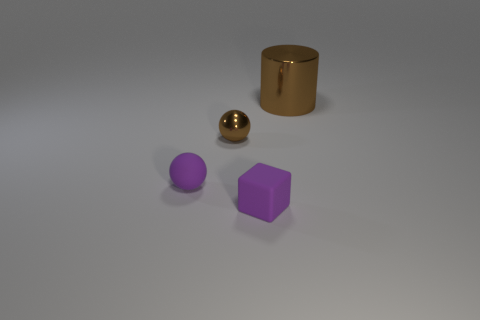Is there any other thing that has the same size as the brown cylinder?
Offer a very short reply. No. Are there more small brown balls that are on the right side of the tiny brown ball than tiny purple rubber cubes that are on the left side of the big metal thing?
Provide a short and direct response. No. There is a small thing that is in front of the purple ball; what material is it?
Ensure brevity in your answer.  Rubber. Does the tiny brown object have the same shape as the big brown object?
Offer a very short reply. No. Is there anything else that has the same color as the cylinder?
Give a very brief answer. Yes. There is another object that is the same shape as the small brown metallic thing; what color is it?
Your answer should be compact. Purple. Are there more purple balls to the left of the purple matte sphere than large brown cylinders?
Provide a succinct answer. No. There is a shiny thing that is left of the large cylinder; what is its color?
Offer a terse response. Brown. Is the purple cube the same size as the metallic ball?
Keep it short and to the point. Yes. The metallic cylinder is what size?
Keep it short and to the point. Large. 